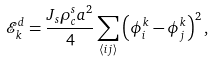Convert formula to latex. <formula><loc_0><loc_0><loc_500><loc_500>\mathcal { E } _ { k } ^ { d } = \frac { J _ { s } \rho _ { c } ^ { s } a ^ { 2 } } 4 \sum _ { \left \langle i j \right \rangle } \left ( \phi _ { i } ^ { k } - \phi _ { j } ^ { k } \right ) ^ { 2 } ,</formula> 